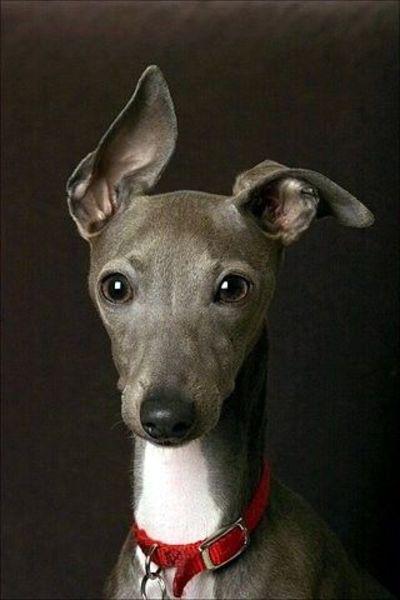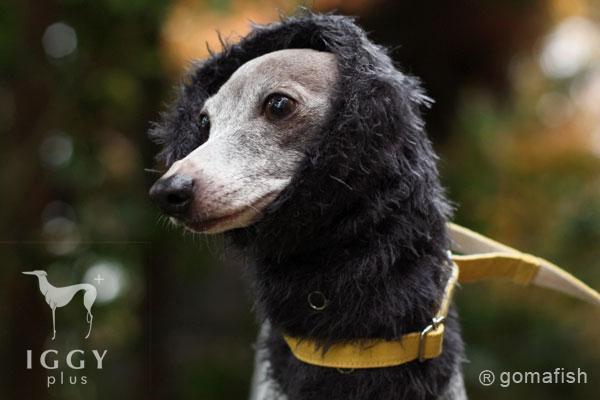The first image is the image on the left, the second image is the image on the right. Evaluate the accuracy of this statement regarding the images: "At least one of the dogs in the image on the left is standing on all four legs.". Is it true? Answer yes or no. No. The first image is the image on the left, the second image is the image on the right. For the images shown, is this caption "A hound wears a turtle-neck wrap in one image, and the other image shows a hound wearing a dog collar." true? Answer yes or no. Yes. 